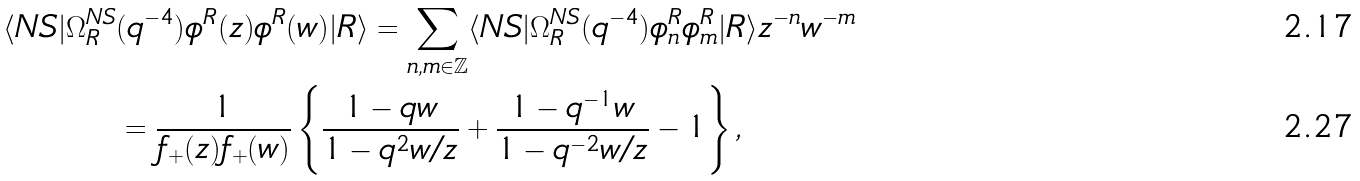Convert formula to latex. <formula><loc_0><loc_0><loc_500><loc_500>\langle N S | \Omega _ { R } ^ { N S } & ( q ^ { - 4 } ) \phi ^ { R } ( z ) \phi ^ { R } ( w ) | R \rangle = \sum _ { n , m \in \mathbb { Z } } \langle N S | \Omega _ { R } ^ { N S } ( q ^ { - 4 } ) \phi ^ { R } _ { n } \phi ^ { R } _ { m } | R \rangle z ^ { - n } w ^ { - m } \\ & = \frac { 1 } { f _ { + } ( z ) f _ { + } ( w ) } \left \{ \frac { 1 - q w } { 1 - q ^ { 2 } w / z } + \frac { 1 - q ^ { - 1 } w } { 1 - q ^ { - 2 } w / z } - 1 \right \} ,</formula> 